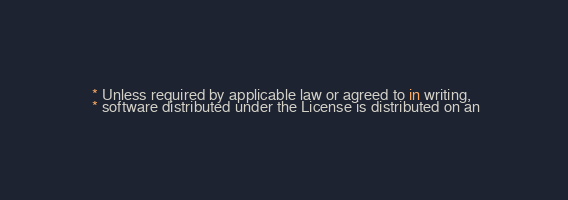Convert code to text. <code><loc_0><loc_0><loc_500><loc_500><_JavaScript_> * Unless required by applicable law or agreed to in writing,
 * software distributed under the License is distributed on an</code> 